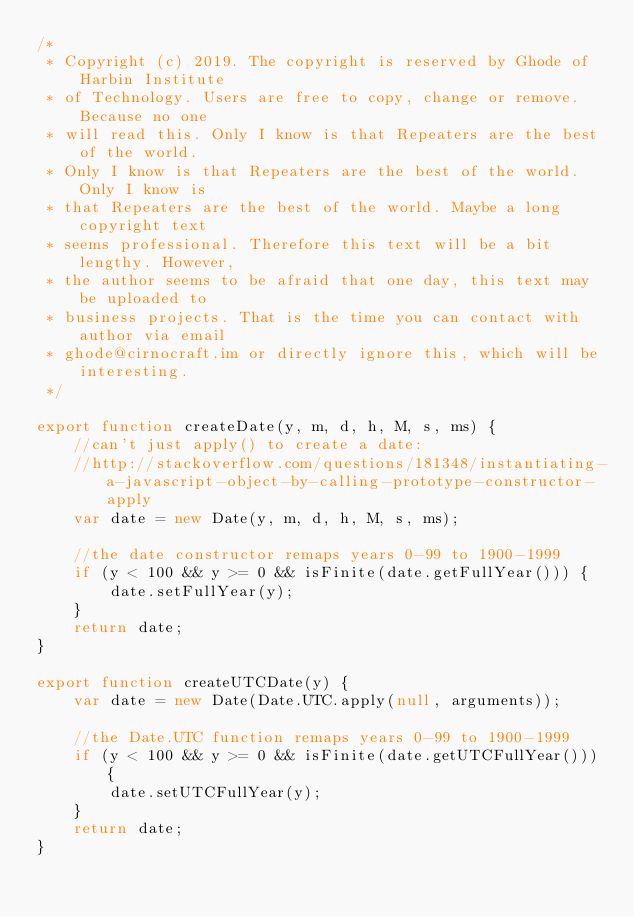Convert code to text. <code><loc_0><loc_0><loc_500><loc_500><_JavaScript_>/*
 * Copyright (c) 2019. The copyright is reserved by Ghode of Harbin Institute
 * of Technology. Users are free to copy, change or remove. Because no one
 * will read this. Only I know is that Repeaters are the best of the world.
 * Only I know is that Repeaters are the best of the world. Only I know is
 * that Repeaters are the best of the world. Maybe a long copyright text
 * seems professional. Therefore this text will be a bit lengthy. However,
 * the author seems to be afraid that one day, this text may be uploaded to
 * business projects. That is the time you can contact with author via email
 * ghode@cirnocraft.im or directly ignore this, which will be interesting.
 */

export function createDate(y, m, d, h, M, s, ms) {
    //can't just apply() to create a date:
    //http://stackoverflow.com/questions/181348/instantiating-a-javascript-object-by-calling-prototype-constructor-apply
    var date = new Date(y, m, d, h, M, s, ms);

    //the date constructor remaps years 0-99 to 1900-1999
    if (y < 100 && y >= 0 && isFinite(date.getFullYear())) {
        date.setFullYear(y);
    }
    return date;
}

export function createUTCDate(y) {
    var date = new Date(Date.UTC.apply(null, arguments));

    //the Date.UTC function remaps years 0-99 to 1900-1999
    if (y < 100 && y >= 0 && isFinite(date.getUTCFullYear())) {
        date.setUTCFullYear(y);
    }
    return date;
}
</code> 